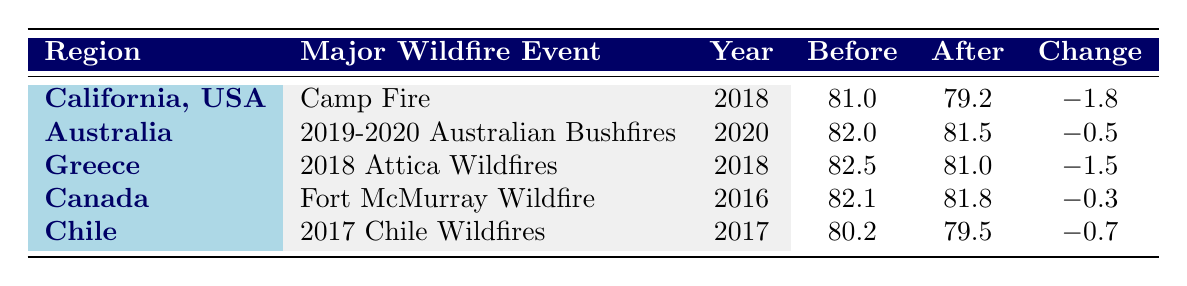What is the life expectancy in California before the Camp Fire? The table shows that the life expectancy in California before the Camp Fire was 81.0 years.
Answer: 81.0 What was the change in life expectancy after the 2018 Attica Wildfires in Greece? According to the table, the change in life expectancy after the 2018 Attica Wildfires was -1.5 years, meaning it decreased from 82.5 to 81.0 years.
Answer: -1.5 Is the life expectancy in Australia after the 2019-2020 Australian Bushfires higher than 81 years? The table indicates that the life expectancy in Australia after the bushfires was 81.5 years, which is indeed higher than 81 years.
Answer: Yes Which major wildfire event resulted in the largest decrease in life expectancy? By examining the changes in life expectancy from the table: Camp Fire (-1.8), 2018 Attica Wildfires (-1.5), Australian Bushfires (-0.5), Fort McMurray (-0.3), and Chile Wildfires (-0.7), the largest decrease was from the Camp Fire at -1.8 years.
Answer: Camp Fire What is the average life expectancy before these major wildfire events? Calculating the average involves summing the life expectancy values before each event: 81.0 + 82.0 + 82.5 + 82.1 + 80.2 = 407.8. Dividing by the number of events (5) gives: 407.8 / 5 = 81.56.
Answer: 81.56 Did the Fort McMurray Wildfire result in a decrease in life expectancy? The data in the table shows that the life expectancy after the Fort McMurray Wildfire was 81.8 years, which is less than the life expectancy before the event (82.1 years). Thus, it indeed resulted in a decrease.
Answer: Yes What is the difference in life expectancy before and after the Chile Wildfires? By looking at the table, the life expectancy before the Chile Wildfires was 80.2 years, and after it was 79.5 years. The difference (or change) is: 80.2 - 79.5 = 0.7 years.
Answer: 0.7 Which region had the highest life expectancy after the major wildfire event? Checking the table values for life expectancy after events: California (79.2), Australia (81.5), Greece (81.0), Canada (81.8), and Chile (79.5), the highest after-event life expectancy is in Australia at 81.5 years.
Answer: Australia 